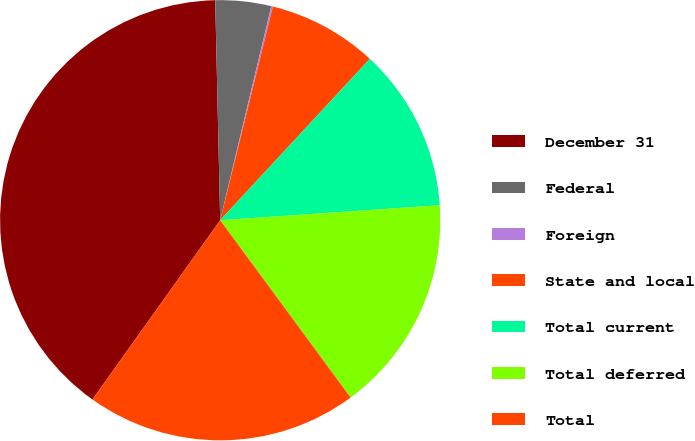Convert chart to OTSL. <chart><loc_0><loc_0><loc_500><loc_500><pie_chart><fcel>December 31<fcel>Federal<fcel>Foreign<fcel>State and local<fcel>Total current<fcel>Total deferred<fcel>Total<nl><fcel>39.79%<fcel>4.09%<fcel>0.12%<fcel>8.05%<fcel>12.02%<fcel>15.99%<fcel>19.95%<nl></chart> 